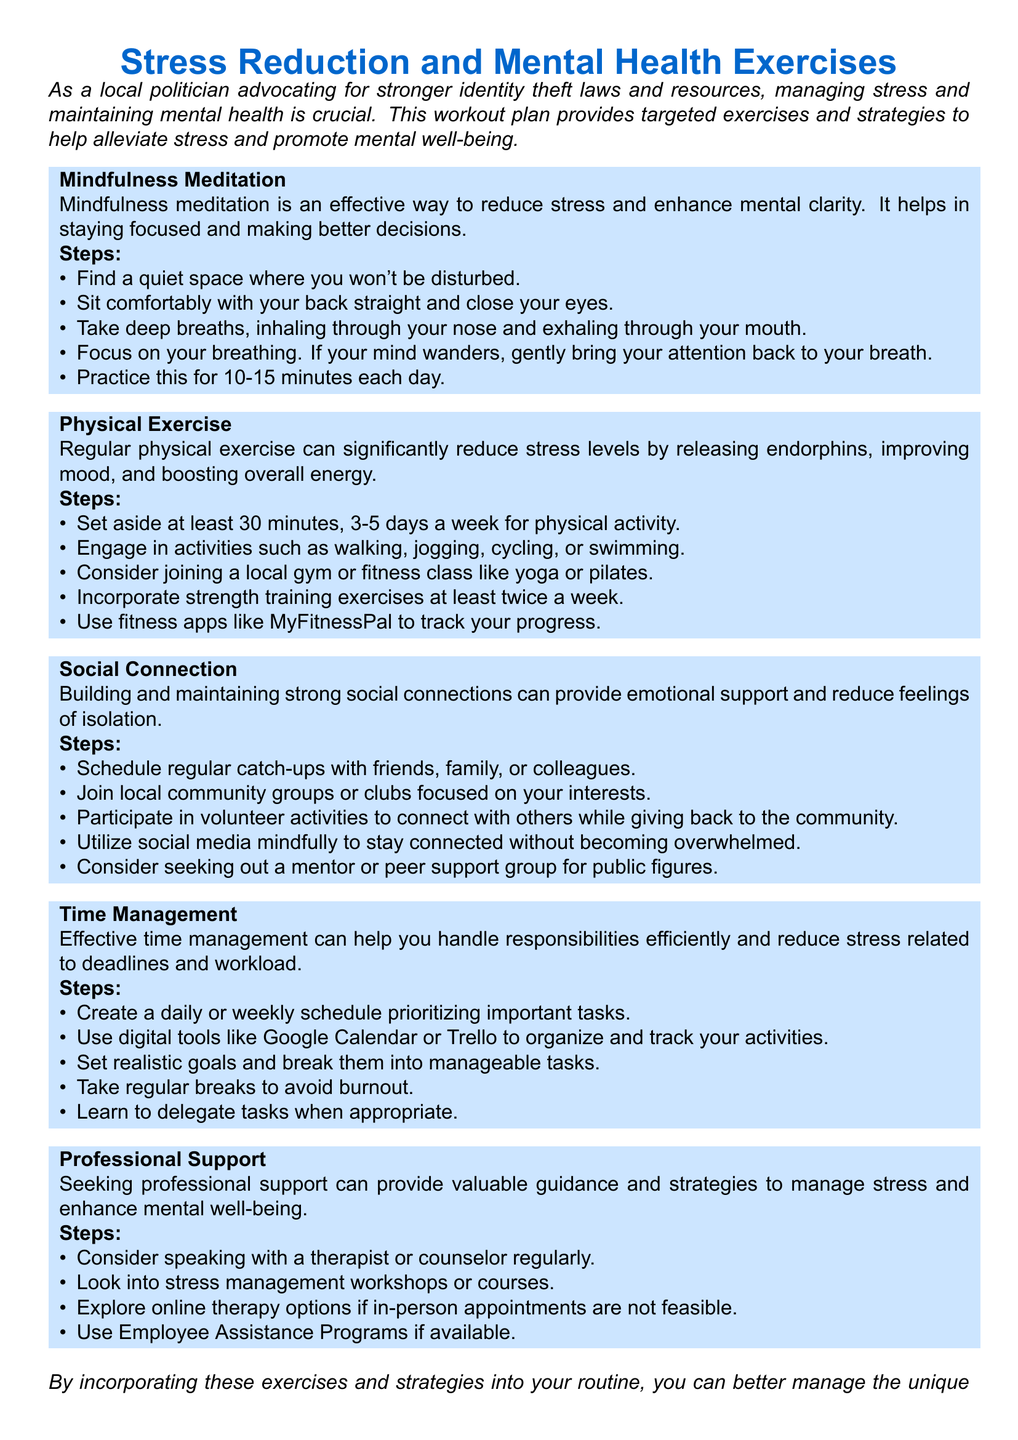What is the main focus of the document? The main focus of the document is on stress reduction and mental health exercises for public figures.
Answer: stress reduction and mental health exercises How many steps are outlined for mindfulness meditation? The document specifies five steps for mindfulness meditation.
Answer: 5 What is the recommended duration for physical exercise per week? The suggested duration for physical exercise is at least 30 minutes, 3-5 days a week.
Answer: 30 minutes, 3-5 days What type of support does the document suggest for public figures? The document suggests seeking professional support from therapists or counselors.
Answer: professional support What digital tools are mentioned for time management? The digital tools referenced for time management include Google Calendar and Trello.
Answer: Google Calendar and Trello How often should you practice mindfulness meditation? Mindfulness meditation should be practiced daily.
Answer: daily Which exercise promotes building social connections? The exercise that promotes building social connections is engaging in volunteer activities.
Answer: volunteer activities What is one benefit of physical exercise according to the document? One benefit of physical exercise mentioned is the release of endorphins.
Answer: release of endorphins How can effective time management help reduce stress? Effective time management helps handle responsibilities efficiently, reducing stress related to deadlines and workload.
Answer: handle responsibilities efficiently 